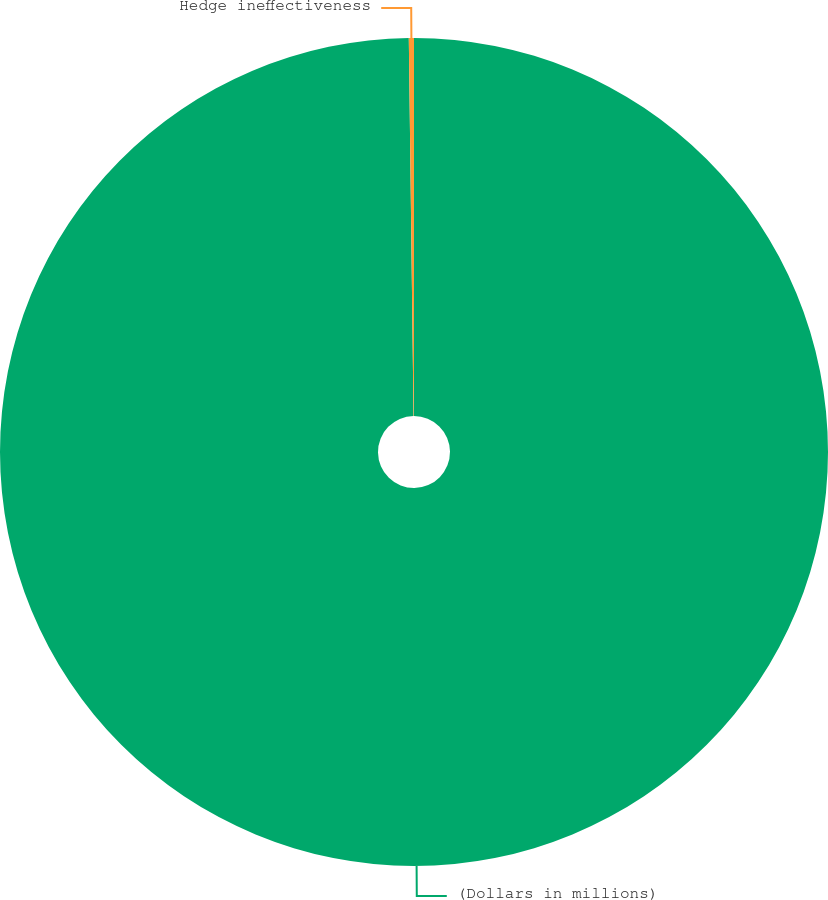<chart> <loc_0><loc_0><loc_500><loc_500><pie_chart><fcel>(Dollars in millions)<fcel>Hedge ineffectiveness<nl><fcel>99.8%<fcel>0.2%<nl></chart> 